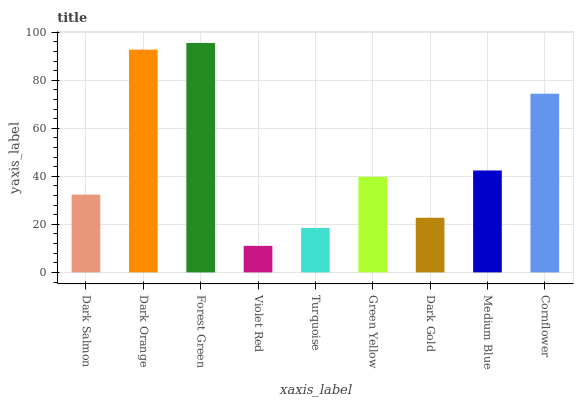Is Violet Red the minimum?
Answer yes or no. Yes. Is Forest Green the maximum?
Answer yes or no. Yes. Is Dark Orange the minimum?
Answer yes or no. No. Is Dark Orange the maximum?
Answer yes or no. No. Is Dark Orange greater than Dark Salmon?
Answer yes or no. Yes. Is Dark Salmon less than Dark Orange?
Answer yes or no. Yes. Is Dark Salmon greater than Dark Orange?
Answer yes or no. No. Is Dark Orange less than Dark Salmon?
Answer yes or no. No. Is Green Yellow the high median?
Answer yes or no. Yes. Is Green Yellow the low median?
Answer yes or no. Yes. Is Dark Salmon the high median?
Answer yes or no. No. Is Turquoise the low median?
Answer yes or no. No. 